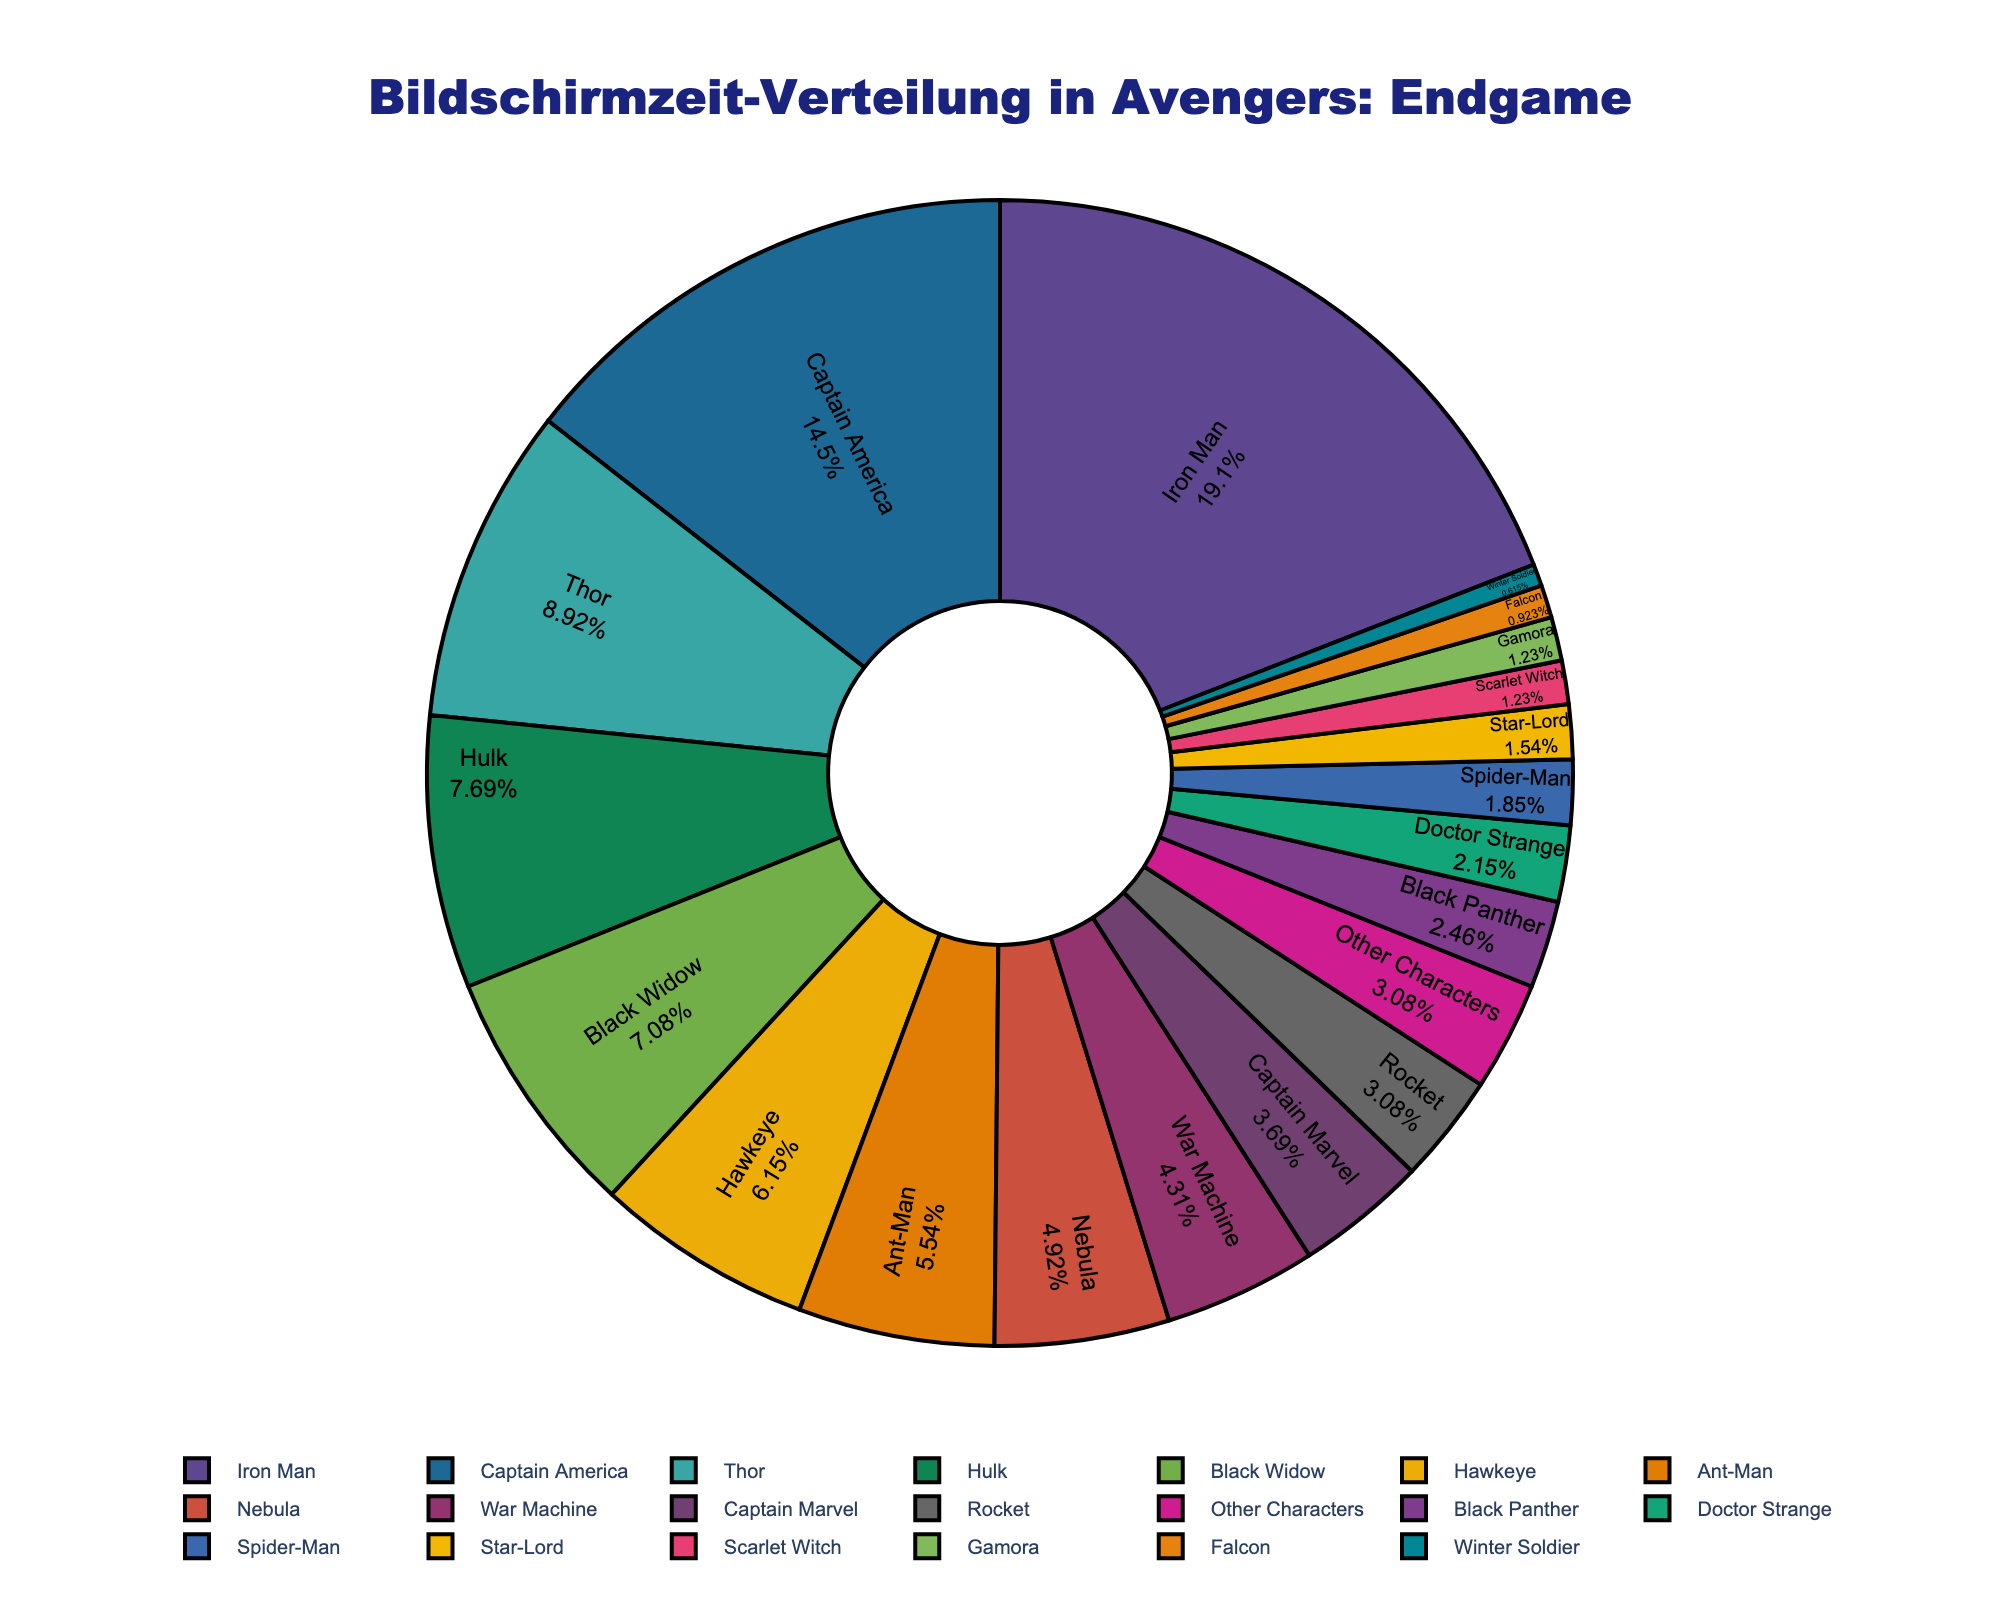Which character has the highest screen time in Avengers: Endgame? To determine the character with the highest screen time, look for the largest section of the pie chart. The character labeled as "Iron Man" occupies the largest part.
Answer: Iron Man Which two characters have the closest screen times, and what are those times? Observe the pie sections that are closest in size. "Ant-Man" has 18 minutes, and "Nebula" has 16 minutes, having the closest screen times.
Answer: Ant-Man (18 minutes), Nebula (16 minutes) How much more screen time does Iron Man have compared to Captain America? From the chart, Iron Man has 62 minutes and Captain America has 47 minutes. Subtract Captain America's screen time from Iron Man's: 62 - 47 = 15 minutes.
Answer: 15 minutes What is the combined screen time of Thor, Hulk, and Black Widow? Sum the screen times of Thor (29 minutes), Hulk (25 minutes), and Black Widow (23 minutes). 29 + 25 + 23 = 77 minutes.
Answer: 77 minutes Who has more screen time, War Machine or Captain Marvel, and by how much? Compare War Machine's 14 minutes and Captain Marvel's 12 minutes. Subtract the smaller value from the larger value: 14 - 12 = 2 minutes.
Answer: War Machine, 2 minutes What percentage of the total screen time is occupied by secondary characters (characters other than Iron Man and Captain America)? Sum all screen times (314 minutes) and subtract Iron Man's (62 minutes) and Captain America's (47 minutes) times to get the secondary characters' screen time (314 - 62 - 47 = 205 minutes). Then, calculate the percentage: (205 / 314) * 100 ≈ 65.29%.
Answer: Approximately 65.29% Which character has a screen time of over 10 minutes but less than 20 minutes? Look for sections labeled with values between 10 and 20 minutes. Hawkeye (20 minutes), Ant-Man (18 minutes), Nebula (16 minutes), and War Machine (14 minutes) fit this range.
Answer: Hawkeye, Ant-Man, Nebula, War Machine Is the screen time of Rocket greater than the combined screen time of Doctor Strange and Spider-Man? Rocket has 10 minutes. Doctor Strange and Spider-Man together have 7 + 6 = 13 minutes, so Rocket’s screen time is less.
Answer: No What is the average screen time of the characters who have less than 10 minutes of screen time each? Find screen times less than 10 minutes: Black Panther (8), Doctor Strange (7), Spider-Man (6), Star-Lord (5), Scarlet Witch (4), Gamora (4), Falcon (3), Winter Soldier (2). Sum: 8 + 7 + 6 + 5 + 4 + 4 + 3 + 2 = 39. Count: 8 characters. Average: 39 / 8 ≈ 4.875 minutes.
Answer: Approximately 4.875 minutes Which character with less than 10 minutes of screen time occupies the smallest section of the pie chart? Among characters with screen time under 10 minutes (Black Panther, Doctor Strange, Spider-Man, Star-Lord, Scarlet Witch, Gamora, Falcon, Winter Soldier), the character with the lowest screen time is Winter Soldier with 2 minutes.
Answer: Winter Soldier 